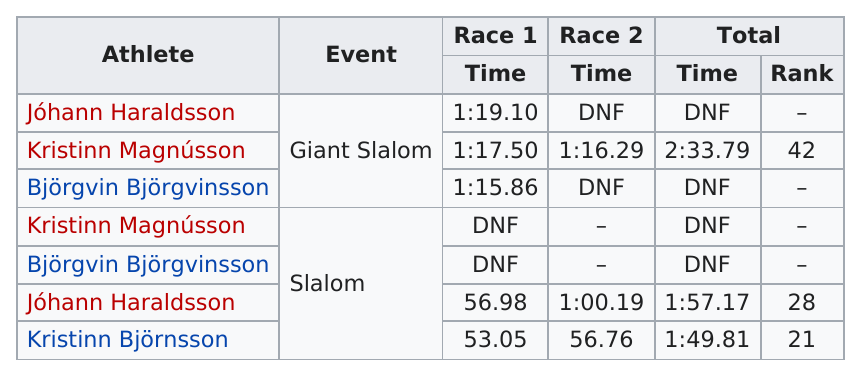Point out several critical features in this image. There are 3 men who did not finish. After the completion of Race 1, a total of 5 athletes have finished the race. I am aware of a person named Bjorgvinsson who did not finish a race, and another person named Jóhann Haraldsson who also did not finish a race. In the men's alpine skiing event, the slalom had the highest number of Icelandic competitors, with a total of [number of competitors] participating. Haraldsson finished the first race of the slalom in a time of 56.98. 